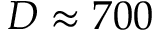Convert formula to latex. <formula><loc_0><loc_0><loc_500><loc_500>D \approx 7 0 0</formula> 